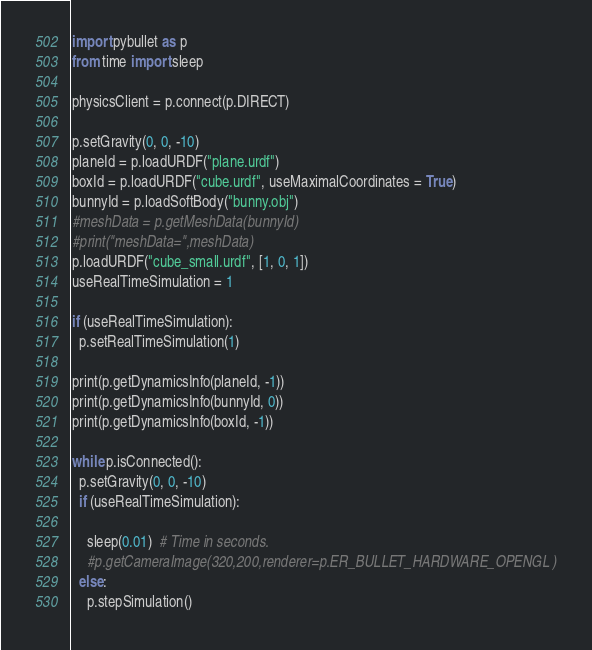Convert code to text. <code><loc_0><loc_0><loc_500><loc_500><_Python_>import pybullet as p
from time import sleep

physicsClient = p.connect(p.DIRECT)

p.setGravity(0, 0, -10)
planeId = p.loadURDF("plane.urdf")
boxId = p.loadURDF("cube.urdf", useMaximalCoordinates = True)
bunnyId = p.loadSoftBody("bunny.obj")
#meshData = p.getMeshData(bunnyId)
#print("meshData=",meshData)
p.loadURDF("cube_small.urdf", [1, 0, 1])
useRealTimeSimulation = 1

if (useRealTimeSimulation):
  p.setRealTimeSimulation(1)

print(p.getDynamicsInfo(planeId, -1))
print(p.getDynamicsInfo(bunnyId, 0))
print(p.getDynamicsInfo(boxId, -1))

while p.isConnected():
  p.setGravity(0, 0, -10)
  if (useRealTimeSimulation):

    sleep(0.01)  # Time in seconds.
    #p.getCameraImage(320,200,renderer=p.ER_BULLET_HARDWARE_OPENGL )
  else:
    p.stepSimulation()
</code> 